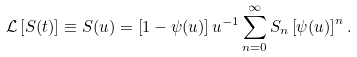Convert formula to latex. <formula><loc_0><loc_0><loc_500><loc_500>\mathcal { L } \left [ S ( t ) \right ] \equiv S ( u ) & = \left [ 1 - \psi ( u ) \right ] u ^ { - 1 } \sum _ { n = 0 } ^ { \infty } S _ { n } \left [ \psi ( u ) \right ] ^ { n } .</formula> 